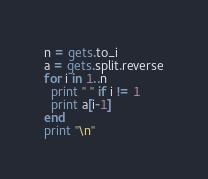Convert code to text. <code><loc_0><loc_0><loc_500><loc_500><_Ruby_>n = gets.to_i
a = gets.split.reverse
for i in 1..n
  print " " if i != 1
  print a[i-1]
end
print "\n"</code> 